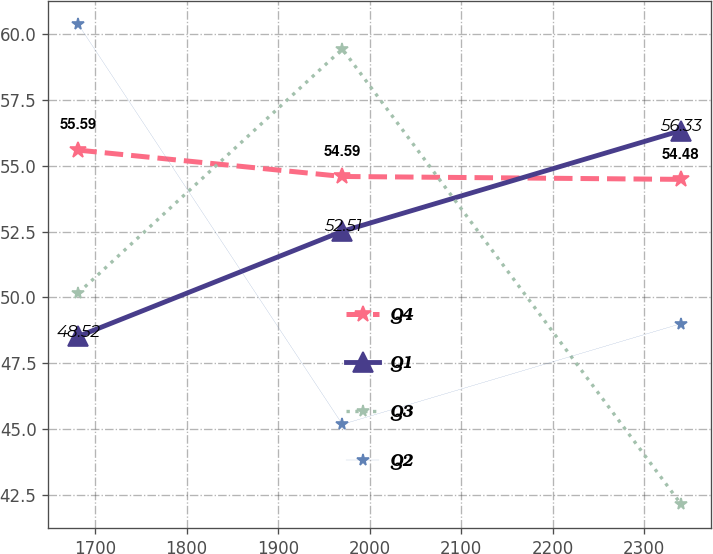<chart> <loc_0><loc_0><loc_500><loc_500><line_chart><ecel><fcel>Q4<fcel>Q1<fcel>Q3<fcel>Q2<nl><fcel>1681.67<fcel>55.59<fcel>48.52<fcel>50.17<fcel>60.36<nl><fcel>1970.19<fcel>54.59<fcel>52.51<fcel>59.43<fcel>45.18<nl><fcel>2340.03<fcel>54.48<fcel>56.33<fcel>42.16<fcel>49<nl></chart> 